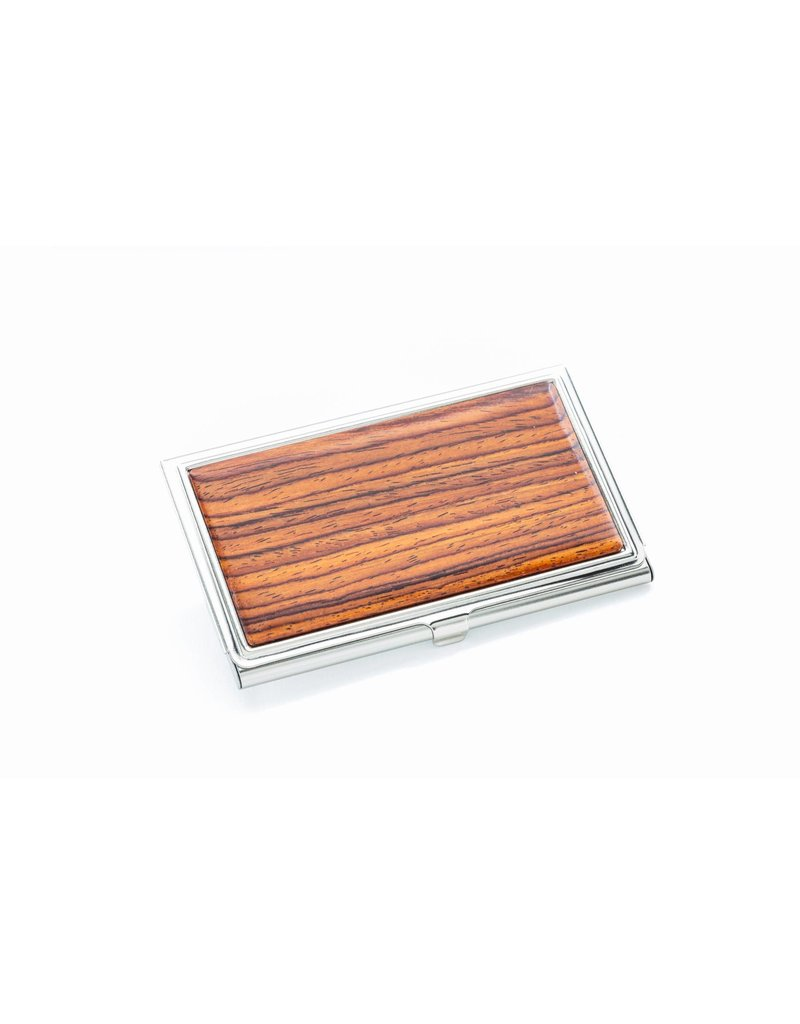What type of wood might the wooden panel on the case be made from, based on the grain pattern and color? Based solely on the image provided, the wooden panel on the case displays a tight, straight grain pattern with a rich, reddish-brown hue. These characteristics are often associated with woods like mahogany or cherry. However, without further tactile or close-up inspection, which might allow for identification of pore patterns or exact color matching, it is not possible to definitively determine the type of wood. Additionally, the image does not rule out the possibility of it being an imitation wood finish on a different material. Therefore, while mahogany or cherry could be candidates, the exact type of wood cannot be conclusively identified from the image alone. 